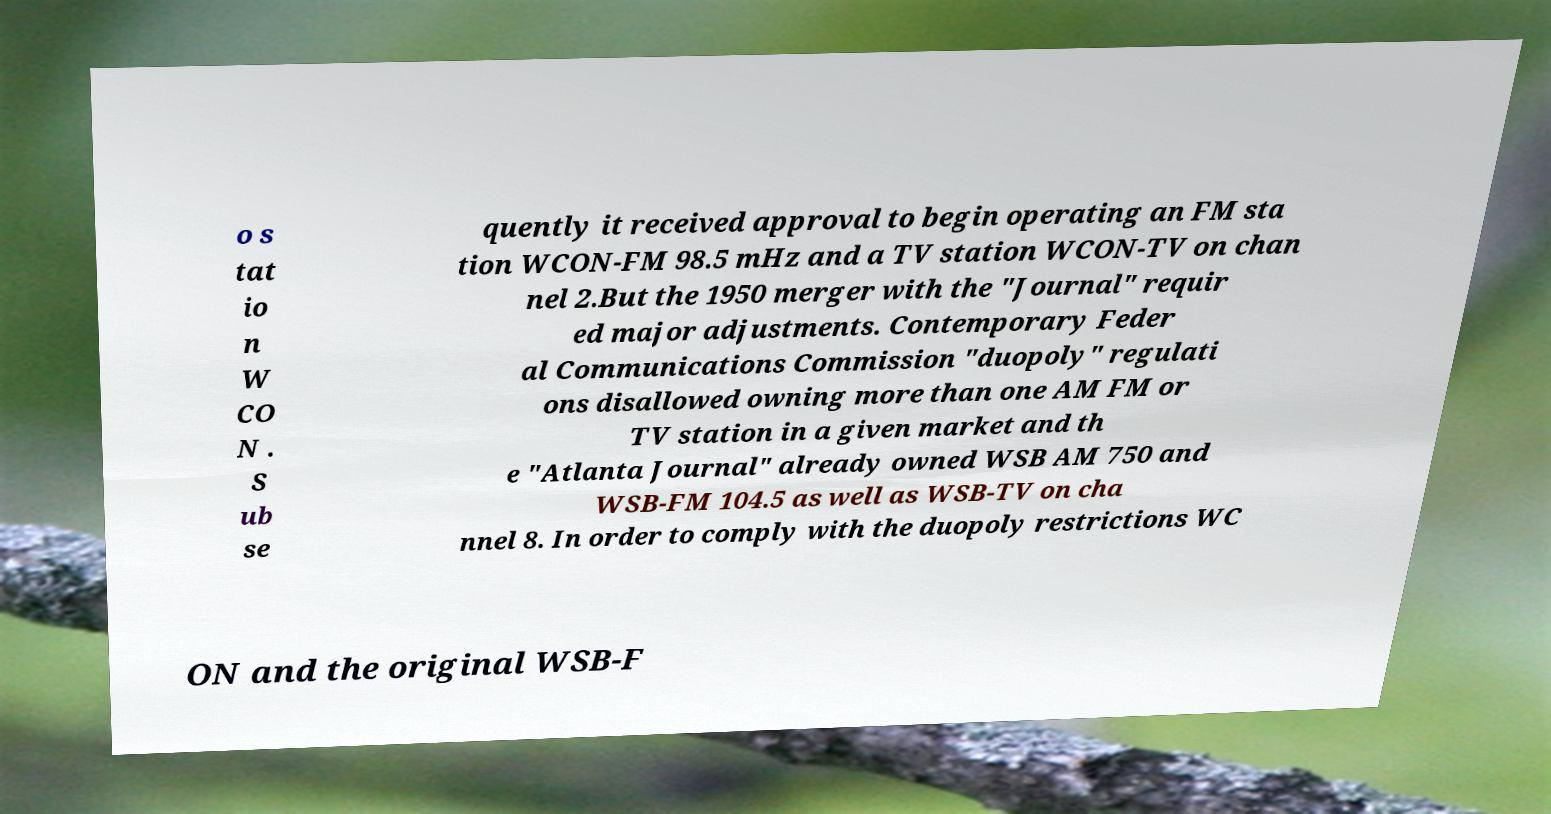For documentation purposes, I need the text within this image transcribed. Could you provide that? o s tat io n W CO N . S ub se quently it received approval to begin operating an FM sta tion WCON-FM 98.5 mHz and a TV station WCON-TV on chan nel 2.But the 1950 merger with the "Journal" requir ed major adjustments. Contemporary Feder al Communications Commission "duopoly" regulati ons disallowed owning more than one AM FM or TV station in a given market and th e "Atlanta Journal" already owned WSB AM 750 and WSB-FM 104.5 as well as WSB-TV on cha nnel 8. In order to comply with the duopoly restrictions WC ON and the original WSB-F 